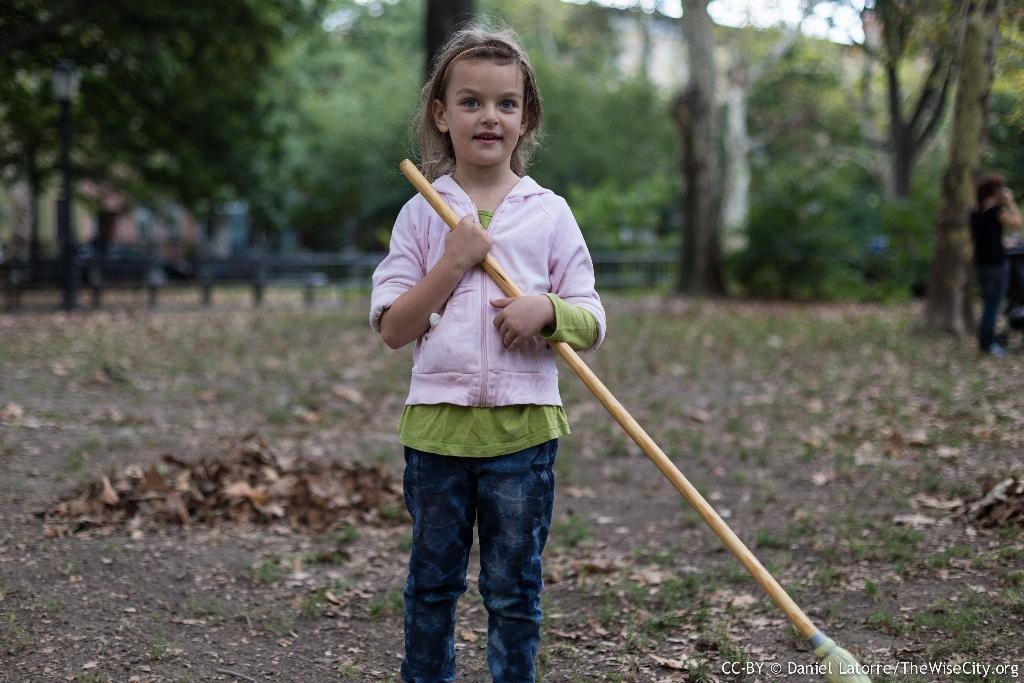What is the main subject of the image? The main subject of the image is a small girl. What is the girl wearing? The girl is wearing a pink jacket. What is the girl holding in her hand? The girl is holding a broomstick in her hand. What is the girl's facial expression? The girl is smiling. What can be seen in the background of the image? There are trees visible in the background of the image. How would you describe the background of the image? The background is blurred. What suggestion: What type of suggestion can be seen written on the broomstick in the image? There is no suggestion written on the broomstick in the image; it is simply a broomstick being held by the girl. friction: What type of friction can be observed between the girl and the broomstick in the image? There is no friction between the girl and the broomstick in the image; they are simply touching. creature: What type of creature can be seen interacting with the girl in the image? There is no creature present in the image; the girl is alone with the broomstick. 